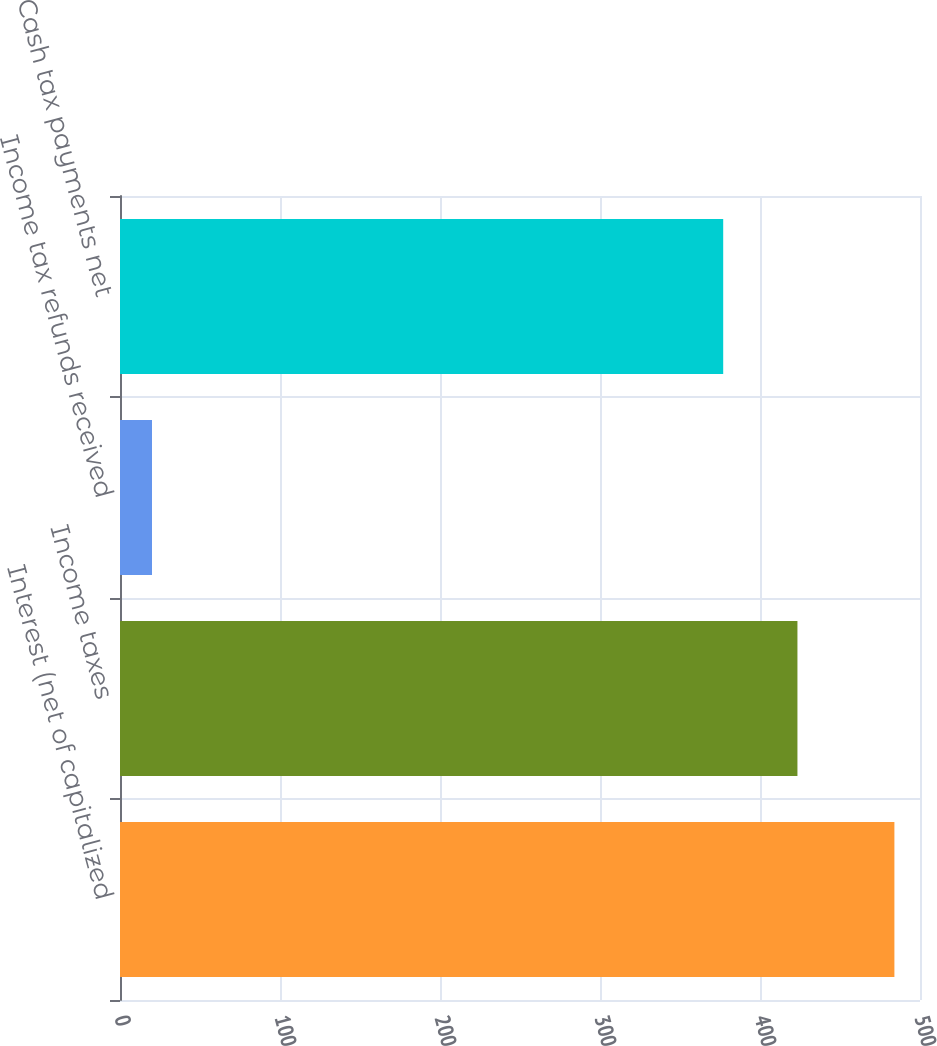Convert chart to OTSL. <chart><loc_0><loc_0><loc_500><loc_500><bar_chart><fcel>Interest (net of capitalized<fcel>Income taxes<fcel>Income tax refunds received<fcel>Cash tax payments net<nl><fcel>484<fcel>423.4<fcel>20<fcel>377<nl></chart> 